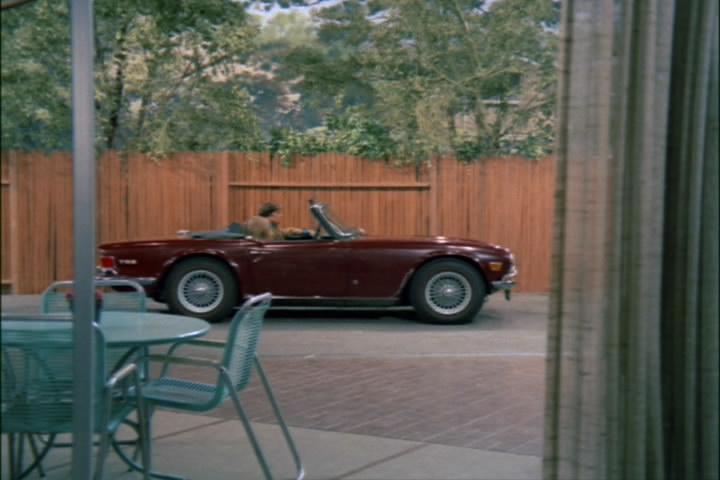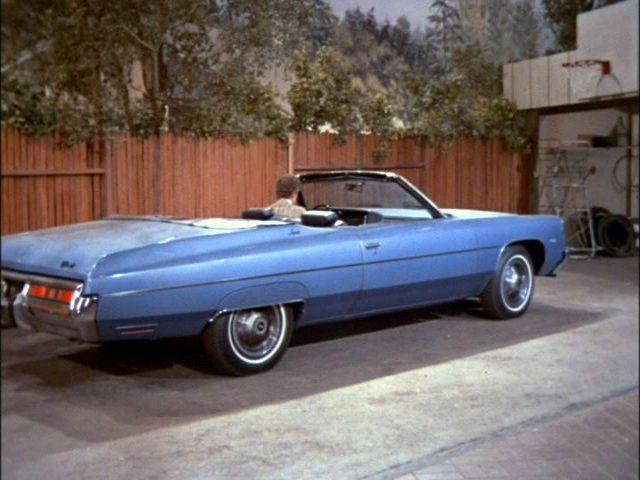The first image is the image on the left, the second image is the image on the right. Analyze the images presented: Is the assertion "An image shows a man sitting behind the wheel of a light blue convertible in front of an open garage." valid? Answer yes or no. Yes. The first image is the image on the left, the second image is the image on the right. Considering the images on both sides, is "No one is sitting in the car in the image on the left." valid? Answer yes or no. No. 